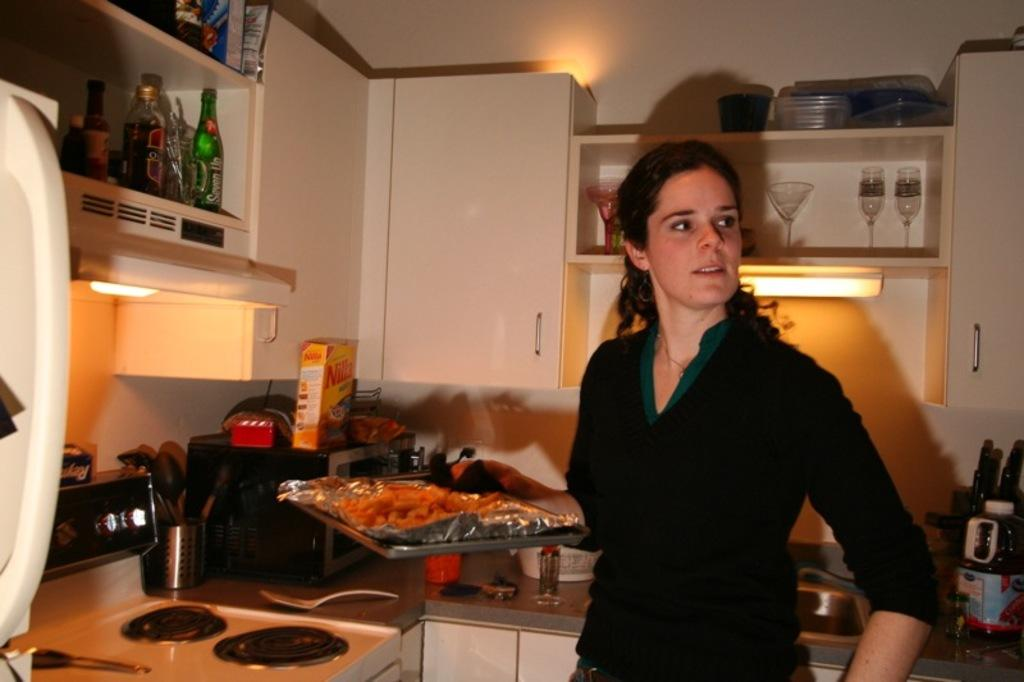Provide a one-sentence caption for the provided image. A box of Nilla wafers on the counter behind the woman. 